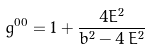<formula> <loc_0><loc_0><loc_500><loc_500>g ^ { 0 0 } = 1 + \frac { 4 E ^ { 2 } } { b ^ { 2 } - 4 \, E ^ { 2 } }</formula> 